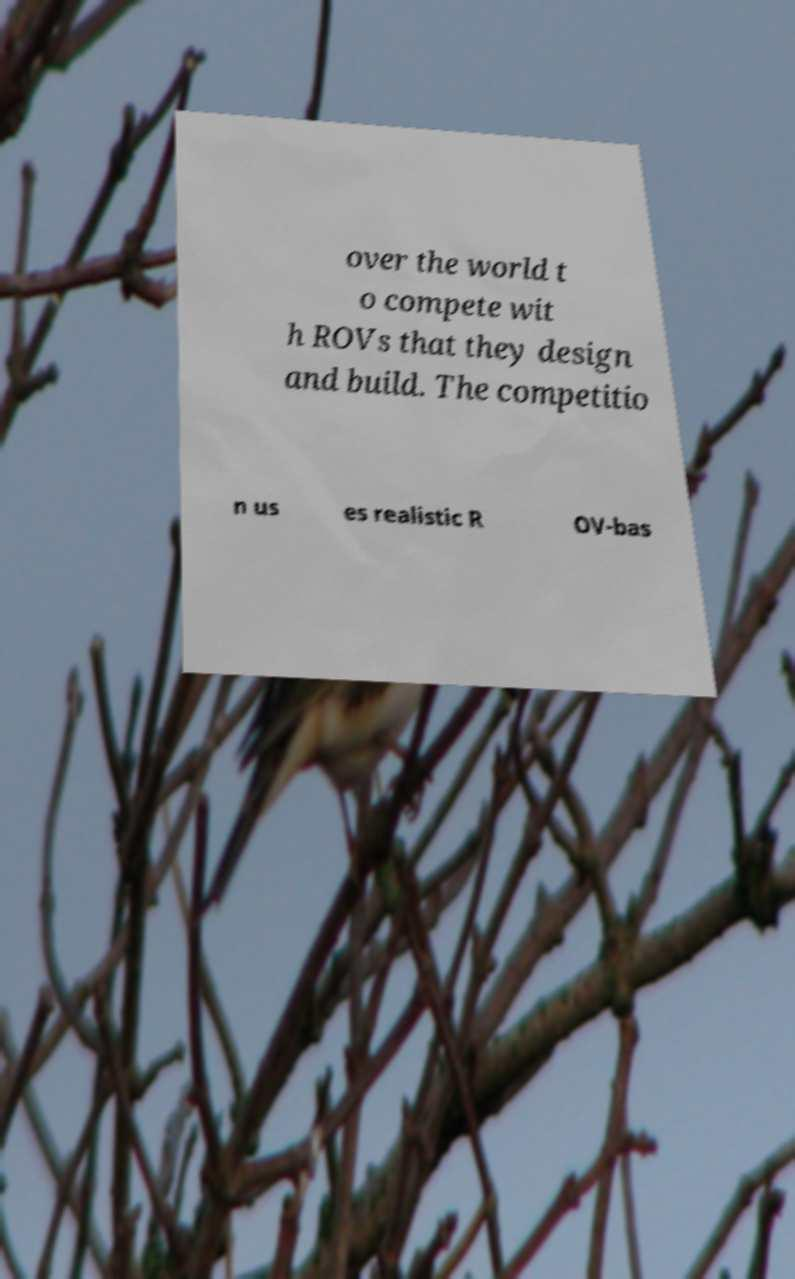Please identify and transcribe the text found in this image. over the world t o compete wit h ROVs that they design and build. The competitio n us es realistic R OV-bas 